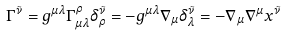Convert formula to latex. <formula><loc_0><loc_0><loc_500><loc_500>\Gamma ^ { \tilde { \nu } } = g ^ { \mu \lambda } \Gamma ^ { \rho } _ { \mu \lambda } \delta ^ { \tilde { \nu } } _ { \rho } = - g ^ { \mu \lambda } \nabla _ { \mu } \delta ^ { \tilde { \nu } } _ { \lambda } = - \nabla _ { \mu } \nabla ^ { \mu } x ^ { \tilde { \nu } }</formula> 